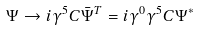Convert formula to latex. <formula><loc_0><loc_0><loc_500><loc_500>\Psi \rightarrow i \gamma ^ { 5 } C \bar { \Psi } ^ { T } = i \gamma ^ { 0 } \gamma ^ { 5 } C \Psi ^ { * }</formula> 